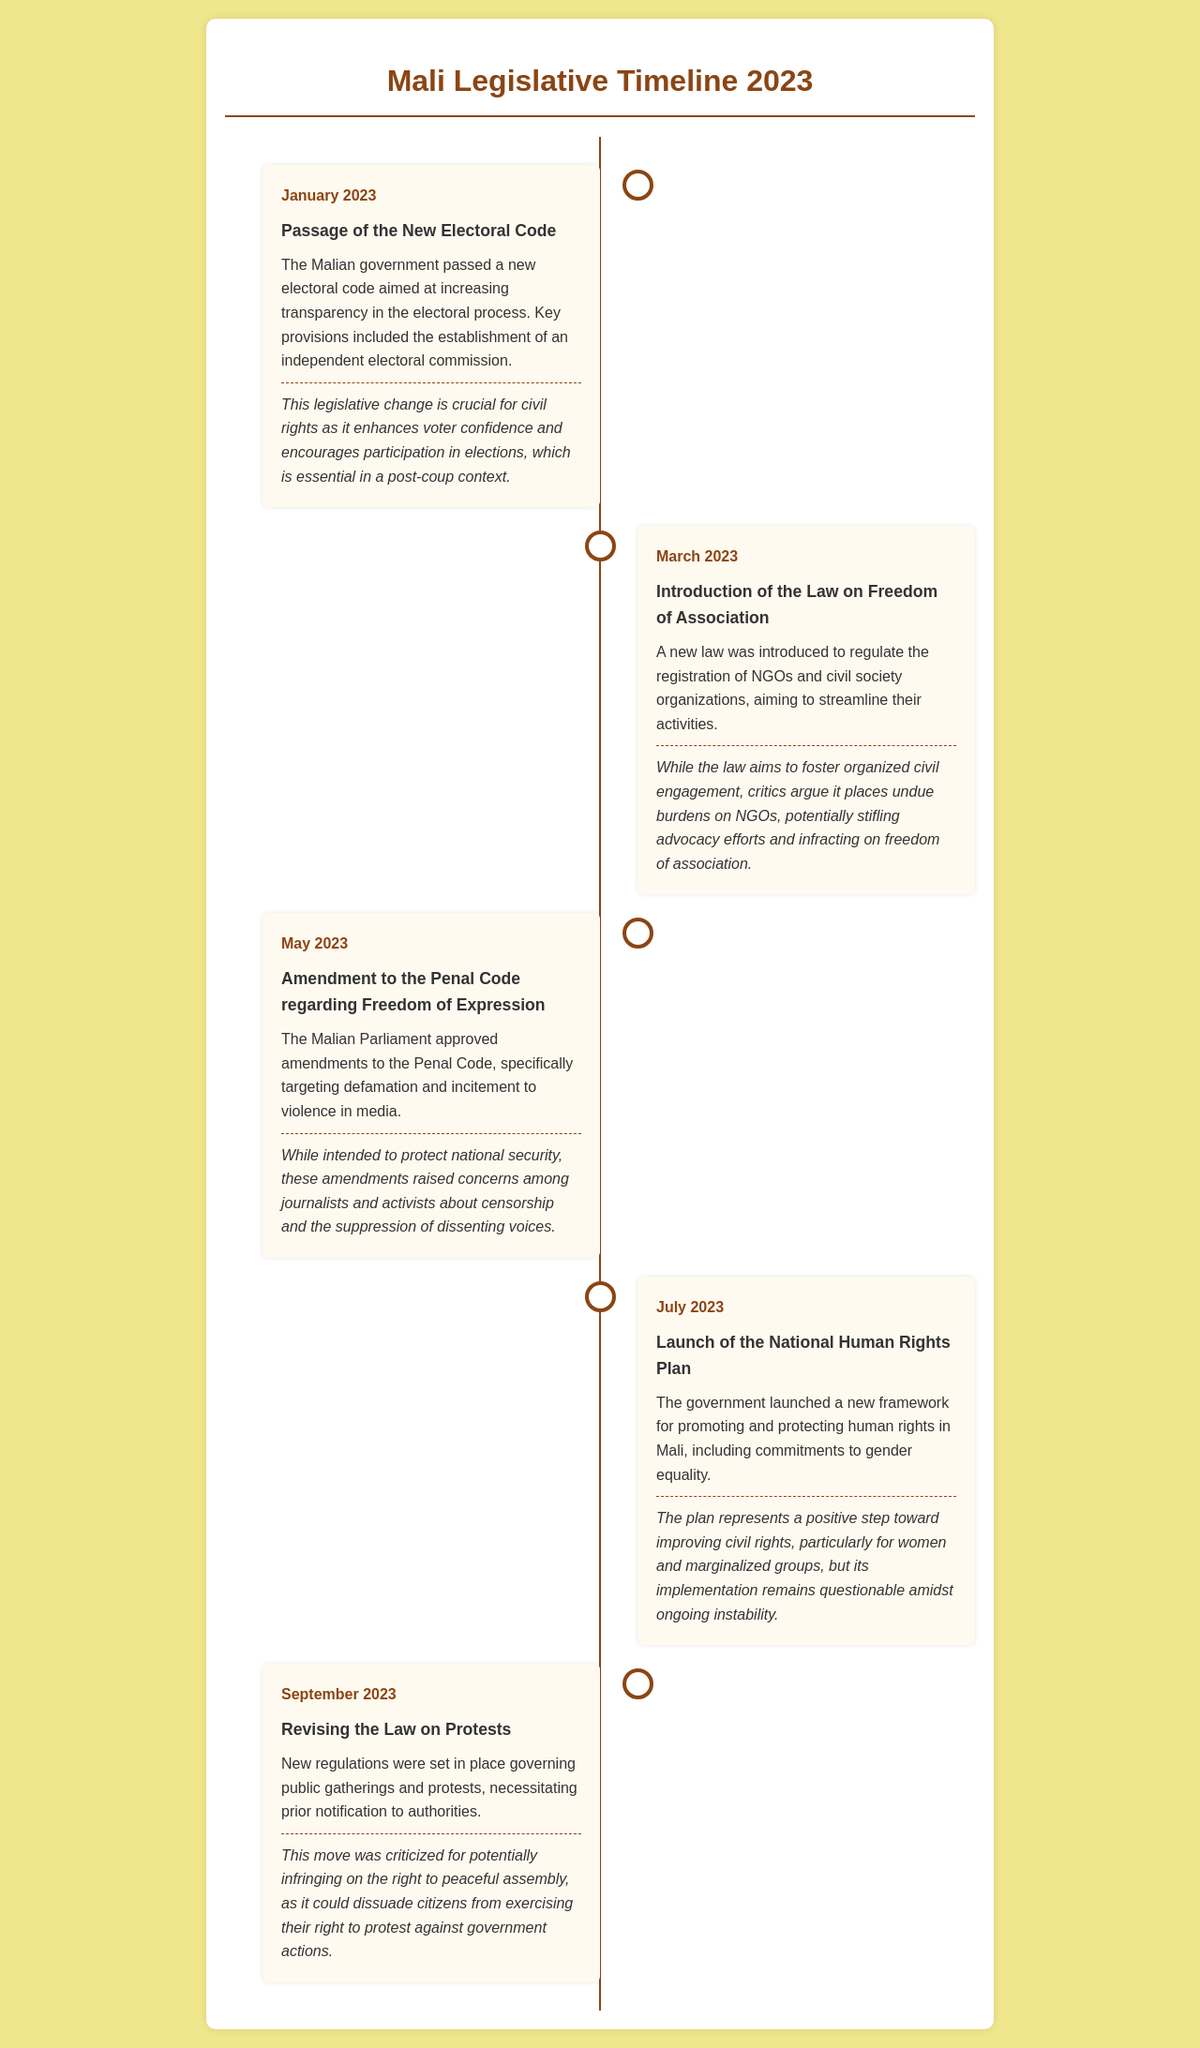What date was the New Electoral Code passed? The document states that the New Electoral Code was passed in January 2023.
Answer: January 2023 What is the focus of the Law on Freedom of Association? The document mentions that the Law on Freedom of Association regulates the registration of NGOs and civil society organizations.
Answer: Registration of NGOs What month was the National Human Rights Plan launched? According to the document, the National Human Rights Plan was launched in July 2023.
Answer: July 2023 What amendment was made to the Penal Code in May? The amendment made involved targeting defamation and incitement to violence in media.
Answer: Defamation What impact does the new regulation on protests have? The document indicates that the regulation could potentially infringe on the right to peaceful assembly.
Answer: Infringe on assembly What does the new electoral code aim to enhance? The new electoral code aims to enhance voter confidence and encourage participation in elections.
Answer: Voter confidence What criticism is mentioned regarding the Law on Freedom of Association? Critics argue it places undue burdens on NGOs, potentially stifling advocacy efforts.
Answer: Undue burdens on NGOs What type of legislative change was introduced in March? In March, a new law regulating the registration of NGOs was introduced.
Answer: Freedom of Association How does the National Human Rights Plan affect women? The plan represents a positive step toward improving civil rights for women.
Answer: Improvement for women 